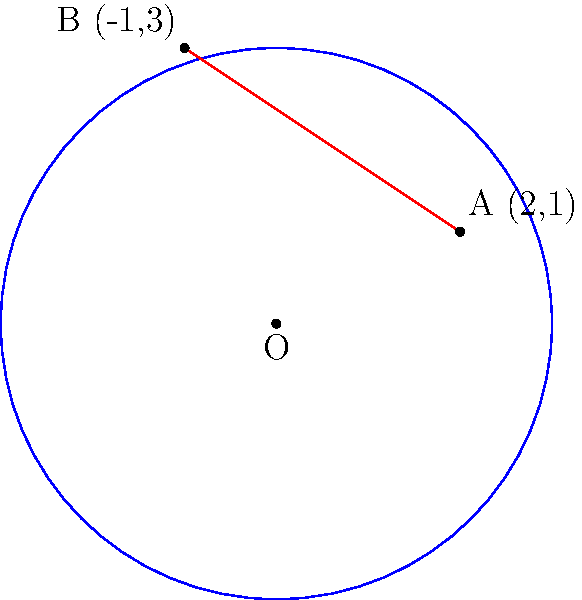As part of integrating the headquarters into the surrounding neighborhood, a circular park is proposed adjacent to the building. The center of the park is at the origin (0,0), and it passes through two important community landmarks: point A (2,1) and point B (-1,3). Determine the equation of the circular boundary for this proposed park area. To find the equation of the circular boundary, we need to follow these steps:

1) The general equation of a circle with center (h,k) and radius r is:
   $$(x-h)^2 + (y-k)^2 = r^2$$

2) We know the center is at (0,0), so h = 0 and k = 0. Our equation simplifies to:
   $$x^2 + y^2 = r^2$$

3) We need to find r. We can use either point A or B to do this, as both lie on the circle. Let's use point A (2,1).

4) Substitute x = 2 and y = 1 into the equation:
   $$2^2 + 1^2 = r^2$$
   $$4 + 1 = r^2$$
   $$5 = r^2$$
   $$r = \sqrt{5}$$

5) Therefore, the equation of the circle is:
   $$x^2 + y^2 = 5$$

6) To verify, we can check if point B (-1,3) satisfies this equation:
   $$(-1)^2 + 3^2 = 1 + 9 = 10$$
   $$\sqrt{10} = \sqrt{5} \cdot \sqrt{2} \approx 3.16$$

   This confirms that B is also on the circle, as its distance from the origin is $\sqrt{10}$, which equals $\sqrt{5} \cdot \sqrt{2}$.
Answer: $x^2 + y^2 = 5$ 